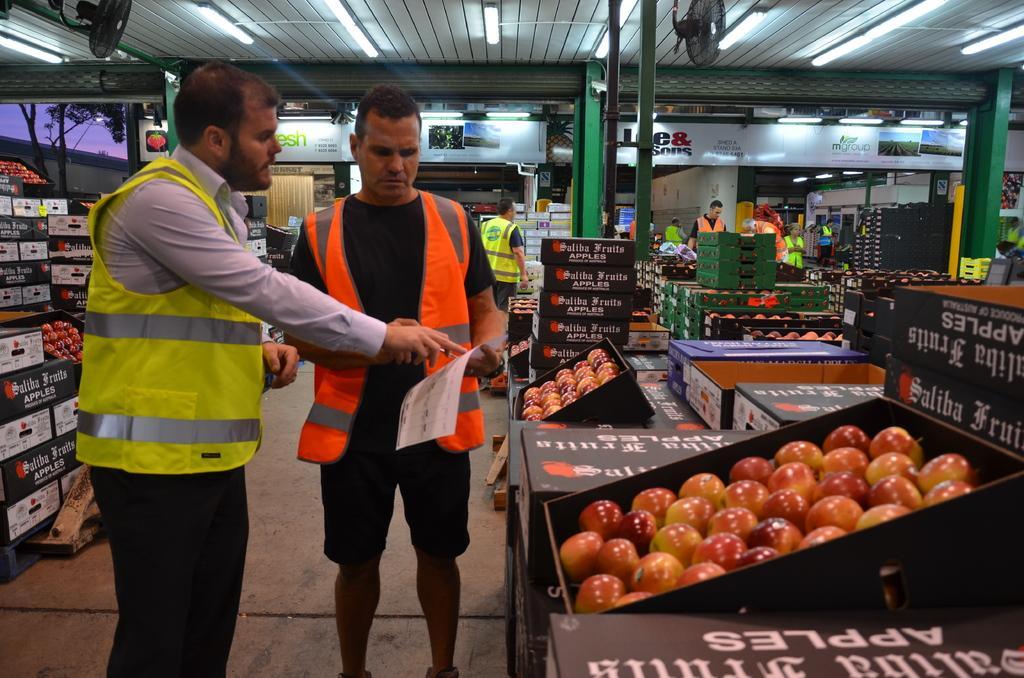Could you give a brief overview of what you see in this image? In this picture there are people, among them there's a man standing and holding a paper. We can see fruits in baskets, boxes, shed, poles, boards and objects. In the background of the image we can see trees and sky. At the top of the image we can see fans and lights. 